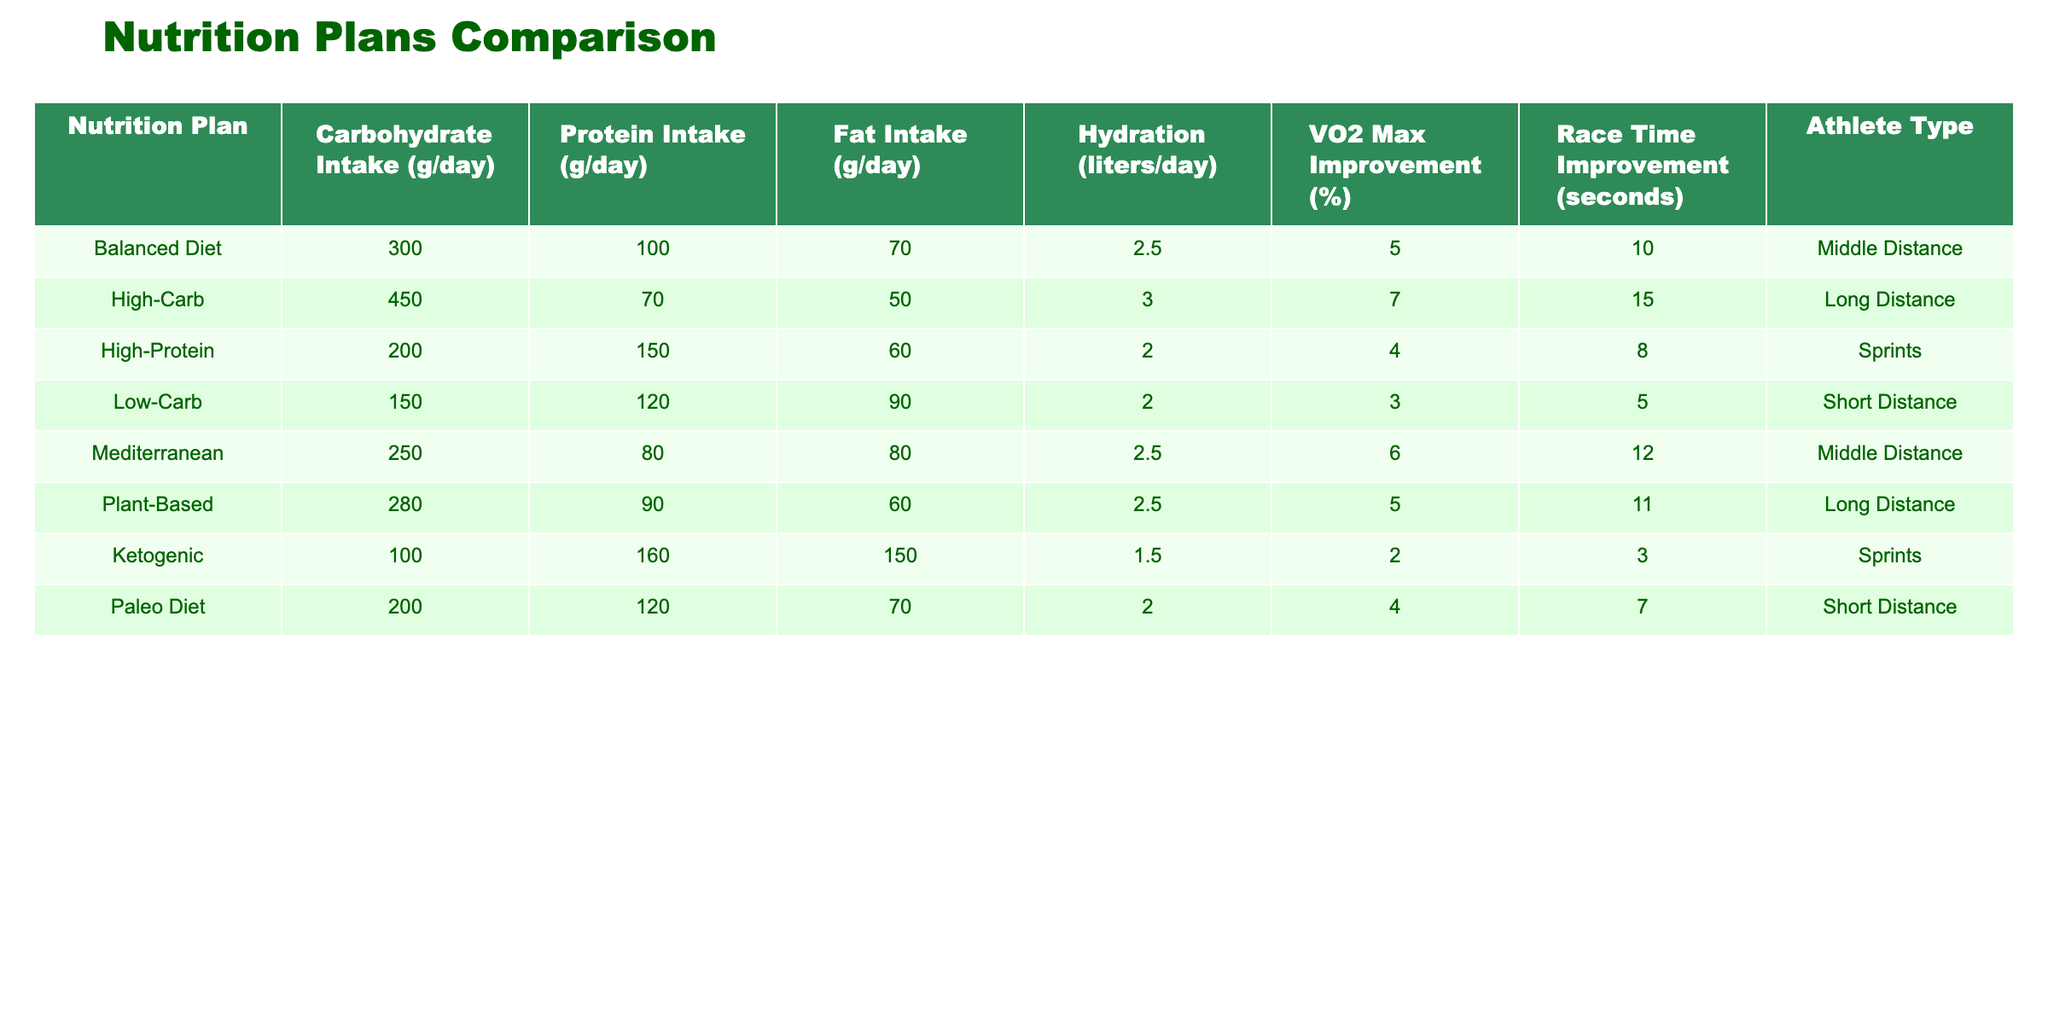What is the highest carbohydrate intake among the nutrition plans? Referring to the table, the highest carbohydrate intake is found in the High-Carb plan, which has a carbohydrate intake of 450 grams per day.
Answer: 450 What improvement in VO2 Max is associated with the Mediterranean diet? By looking at the Mediterranean row in the table, it shows a VO2 Max improvement of 6%.
Answer: 6 Which nutrition plan has the lowest race time improvement? The Low-Carb plan has the lowest race time improvement of 5 seconds, as indicated in the Race Time Improvement column of the table.
Answer: 5 Is the Ketogenic diet associated with more than a 5% improvement in VO2 Max? The table shows a VO2 Max improvement of only 2% for the Ketogenic diet. Therefore, the answer is no.
Answer: No Calculate the average fat intake of the Balanced Diet and Mediterranean diet. The fat intake for the Balanced Diet is 70 grams and for Mediterranean is 80 grams. Adding them gives 70 + 80 = 150 grams. Dividing by 2 results in an average of 75 grams.
Answer: 75 What athlete type has the highest protein intake? Looking at the table, the High-Protein plan has the highest protein intake of 150 grams per day, which is significantly higher than the other plans.
Answer: Sprints Does the High-Carb plan outperform the Balanced Diet in terms of race time improvement? The High-Carb plan shows a race time improvement of 15 seconds compared to the Balanced Diet's improvement of 10 seconds. Since 15 is greater than 10, the answer is yes.
Answer: Yes Which two nutrition plans are associated with middle-distance athletes? The Balanced Diet and Mediterranean diet are both associated with middle-distance athletes according to the Athlete Type column in the table.
Answer: Balanced Diet, Mediterranean What is the difference in race time improvement between the High-Carb plan and the Ketogenic diet? The High-Carb plan has a race time improvement of 15 seconds, while the Ketogenic diet has an improvement of only 3 seconds. The difference is 15 - 3 = 12 seconds.
Answer: 12 